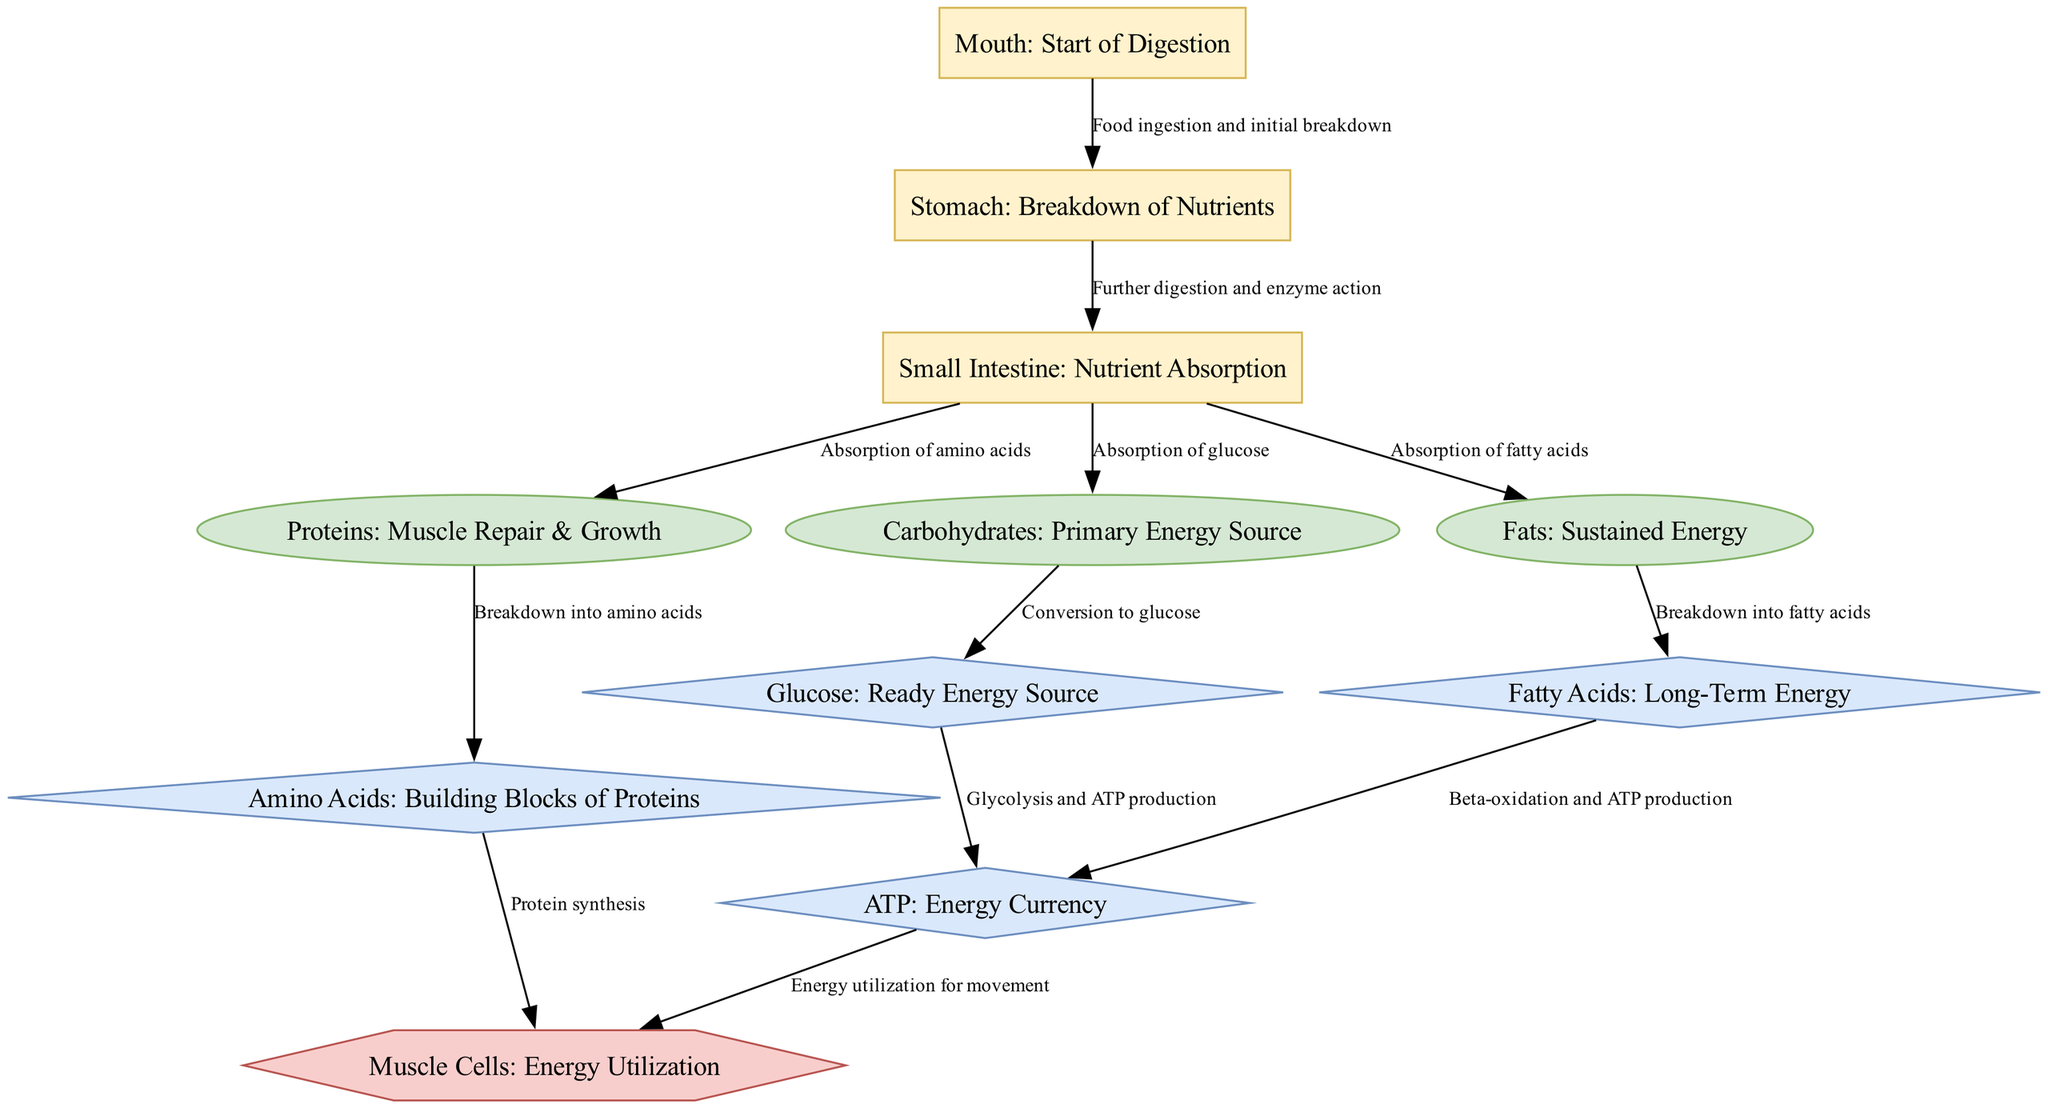What is the starting point of digestion? The diagram indicates that digestion begins at the "Mouth" node, which is labeled as the start of the digestion process.
Answer: Mouth How many nutrients are absorbed in the small intestine? The diagram shows three nutrients absorbing in the small intestine: proteins, carbohydrates, and fats.
Answer: Three What is produced from glucose during energy production? The arrow from glucose leads to the "ATP" node, indicating that ATP is produced via glycolysis, making ATP the primary product.
Answer: ATP What type of biological structure utilizes ATP? The diagram connects ATP to the "Muscle Cells" node, indicating that muscle cells are responsible for utilizing the energy currency ATP.
Answer: Muscle Cells Explain the relationship between fats and fatty acids. The edge labeled "Breakdown into fatty acids" leads from the "Fats" node to the "Fatty Acids" node, showing that fats are broken down to form fatty acids during digestion.
Answer: Breakdown into fatty acids What nutrient is responsible for muscle repair and growth? The "Proteins" node is explicitly labeled as "Muscle Repair & Growth," which directly indicates that proteins are vital for these functions.
Answer: Proteins What process converts carbohydrates into their simplest form? The edge labeled "Conversion to glucose" links carbohydrates to the glucose node, indicating that carbohydrates undergo a conversion process to become glucose, their simplest form.
Answer: Conversion to glucose What are the building blocks of proteins? The diagram connects the "Proteins" node to the "Amino Acids" node with an edge labeled "Breakdown into amino acids," showing that amino acids are the building blocks of proteins.
Answer: Amino Acids How is energy utilized for movement in the body? The diagram states that "Energy utilization for movement" occurs when ATP connects to "Muscle Cells," indicating that ATP provides energy for muscle movements.
Answer: Energy utilization for movement 